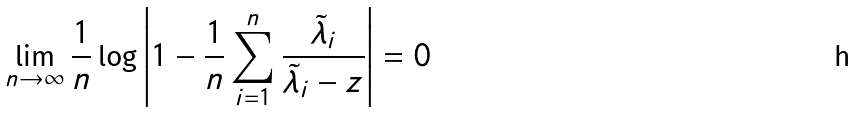<formula> <loc_0><loc_0><loc_500><loc_500>\lim _ { n \to \infty } \frac { 1 } { n } \log \left | 1 - \frac { 1 } { n } \sum _ { i = 1 } ^ { n } \frac { \tilde { \lambda } _ { i } } { \tilde { \lambda } _ { i } - z } \right | = 0</formula> 